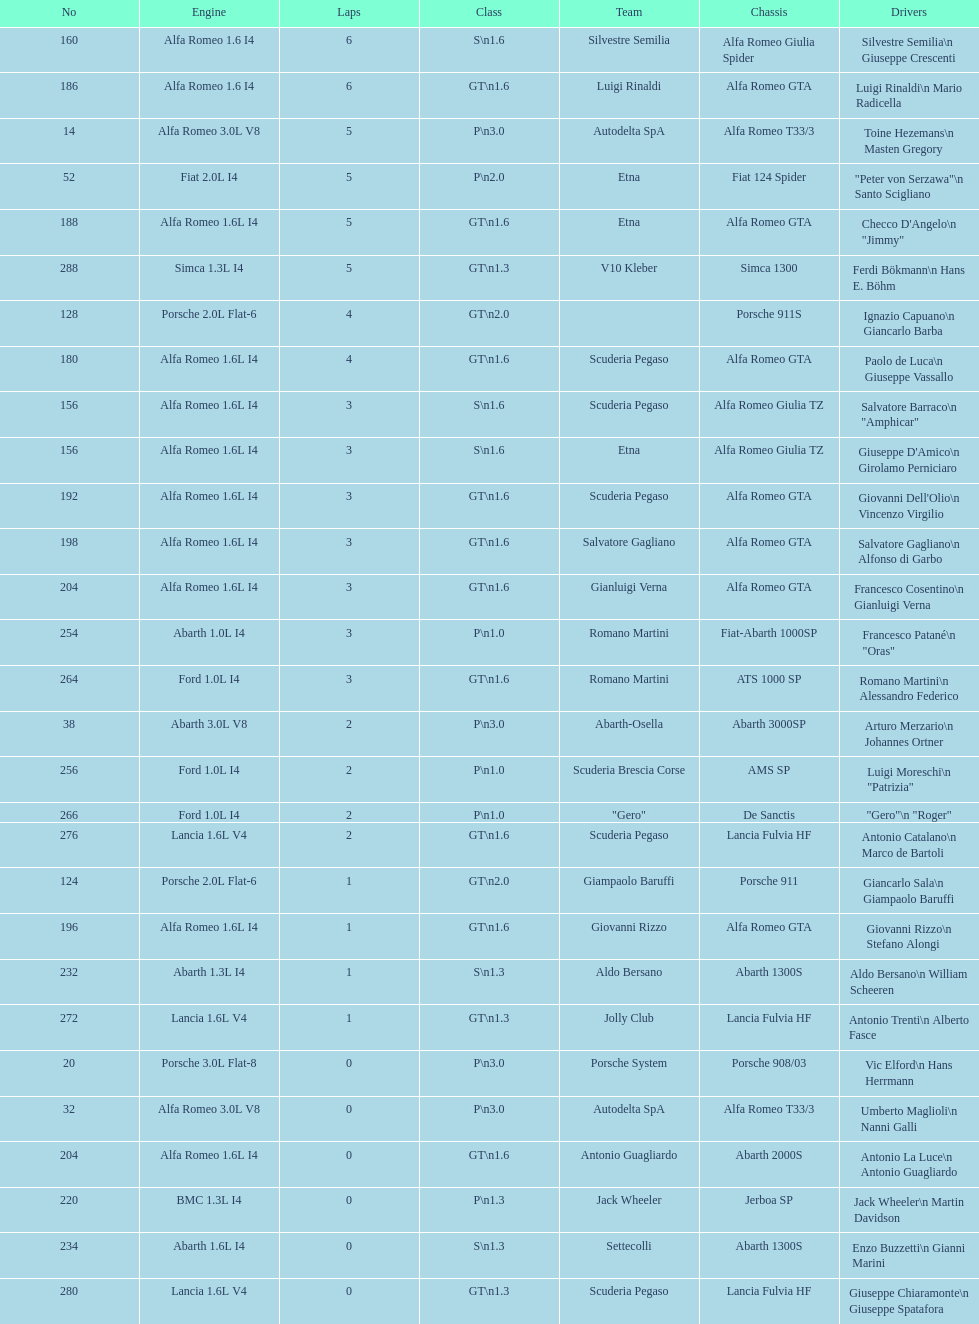His nickname is "jimmy," but what is his full name? Checco D'Angelo. Can you parse all the data within this table? {'header': ['No', 'Engine', 'Laps', 'Class', 'Team', 'Chassis', 'Drivers'], 'rows': [['160', 'Alfa Romeo 1.6 I4', '6', 'S\\n1.6', 'Silvestre Semilia', 'Alfa Romeo Giulia Spider', 'Silvestre Semilia\\n Giuseppe Crescenti'], ['186', 'Alfa Romeo 1.6 I4', '6', 'GT\\n1.6', 'Luigi Rinaldi', 'Alfa Romeo GTA', 'Luigi Rinaldi\\n Mario Radicella'], ['14', 'Alfa Romeo 3.0L V8', '5', 'P\\n3.0', 'Autodelta SpA', 'Alfa Romeo T33/3', 'Toine Hezemans\\n Masten Gregory'], ['52', 'Fiat 2.0L I4', '5', 'P\\n2.0', 'Etna', 'Fiat 124 Spider', '"Peter von Serzawa"\\n Santo Scigliano'], ['188', 'Alfa Romeo 1.6L I4', '5', 'GT\\n1.6', 'Etna', 'Alfa Romeo GTA', 'Checco D\'Angelo\\n "Jimmy"'], ['288', 'Simca 1.3L I4', '5', 'GT\\n1.3', 'V10 Kleber', 'Simca 1300', 'Ferdi Bökmann\\n Hans E. Böhm'], ['128', 'Porsche 2.0L Flat-6', '4', 'GT\\n2.0', '', 'Porsche 911S', 'Ignazio Capuano\\n Giancarlo Barba'], ['180', 'Alfa Romeo 1.6L I4', '4', 'GT\\n1.6', 'Scuderia Pegaso', 'Alfa Romeo GTA', 'Paolo de Luca\\n Giuseppe Vassallo'], ['156', 'Alfa Romeo 1.6L I4', '3', 'S\\n1.6', 'Scuderia Pegaso', 'Alfa Romeo Giulia TZ', 'Salvatore Barraco\\n "Amphicar"'], ['156', 'Alfa Romeo 1.6L I4', '3', 'S\\n1.6', 'Etna', 'Alfa Romeo Giulia TZ', "Giuseppe D'Amico\\n Girolamo Perniciaro"], ['192', 'Alfa Romeo 1.6L I4', '3', 'GT\\n1.6', 'Scuderia Pegaso', 'Alfa Romeo GTA', "Giovanni Dell'Olio\\n Vincenzo Virgilio"], ['198', 'Alfa Romeo 1.6L I4', '3', 'GT\\n1.6', 'Salvatore Gagliano', 'Alfa Romeo GTA', 'Salvatore Gagliano\\n Alfonso di Garbo'], ['204', 'Alfa Romeo 1.6L I4', '3', 'GT\\n1.6', 'Gianluigi Verna', 'Alfa Romeo GTA', 'Francesco Cosentino\\n Gianluigi Verna'], ['254', 'Abarth 1.0L I4', '3', 'P\\n1.0', 'Romano Martini', 'Fiat-Abarth 1000SP', 'Francesco Patané\\n "Oras"'], ['264', 'Ford 1.0L I4', '3', 'GT\\n1.6', 'Romano Martini', 'ATS 1000 SP', 'Romano Martini\\n Alessandro Federico'], ['38', 'Abarth 3.0L V8', '2', 'P\\n3.0', 'Abarth-Osella', 'Abarth 3000SP', 'Arturo Merzario\\n Johannes Ortner'], ['256', 'Ford 1.0L I4', '2', 'P\\n1.0', 'Scuderia Brescia Corse', 'AMS SP', 'Luigi Moreschi\\n "Patrizia"'], ['266', 'Ford 1.0L I4', '2', 'P\\n1.0', '"Gero"', 'De Sanctis', '"Gero"\\n "Roger"'], ['276', 'Lancia 1.6L V4', '2', 'GT\\n1.6', 'Scuderia Pegaso', 'Lancia Fulvia HF', 'Antonio Catalano\\n Marco de Bartoli'], ['124', 'Porsche 2.0L Flat-6', '1', 'GT\\n2.0', 'Giampaolo Baruffi', 'Porsche 911', 'Giancarlo Sala\\n Giampaolo Baruffi'], ['196', 'Alfa Romeo 1.6L I4', '1', 'GT\\n1.6', 'Giovanni Rizzo', 'Alfa Romeo GTA', 'Giovanni Rizzo\\n Stefano Alongi'], ['232', 'Abarth 1.3L I4', '1', 'S\\n1.3', 'Aldo Bersano', 'Abarth 1300S', 'Aldo Bersano\\n William Scheeren'], ['272', 'Lancia 1.6L V4', '1', 'GT\\n1.3', 'Jolly Club', 'Lancia Fulvia HF', 'Antonio Trenti\\n Alberto Fasce'], ['20', 'Porsche 3.0L Flat-8', '0', 'P\\n3.0', 'Porsche System', 'Porsche 908/03', 'Vic Elford\\n Hans Herrmann'], ['32', 'Alfa Romeo 3.0L V8', '0', 'P\\n3.0', 'Autodelta SpA', 'Alfa Romeo T33/3', 'Umberto Maglioli\\n Nanni Galli'], ['204', 'Alfa Romeo 1.6L I4', '0', 'GT\\n1.6', 'Antonio Guagliardo', 'Abarth 2000S', 'Antonio La Luce\\n Antonio Guagliardo'], ['220', 'BMC 1.3L I4', '0', 'P\\n1.3', 'Jack Wheeler', 'Jerboa SP', 'Jack Wheeler\\n Martin Davidson'], ['234', 'Abarth 1.6L I4', '0', 'S\\n1.3', 'Settecolli', 'Abarth 1300S', 'Enzo Buzzetti\\n Gianni Marini'], ['280', 'Lancia 1.6L V4', '0', 'GT\\n1.3', 'Scuderia Pegaso', 'Lancia Fulvia HF', 'Giuseppe Chiaramonte\\n Giuseppe Spatafora']]} 